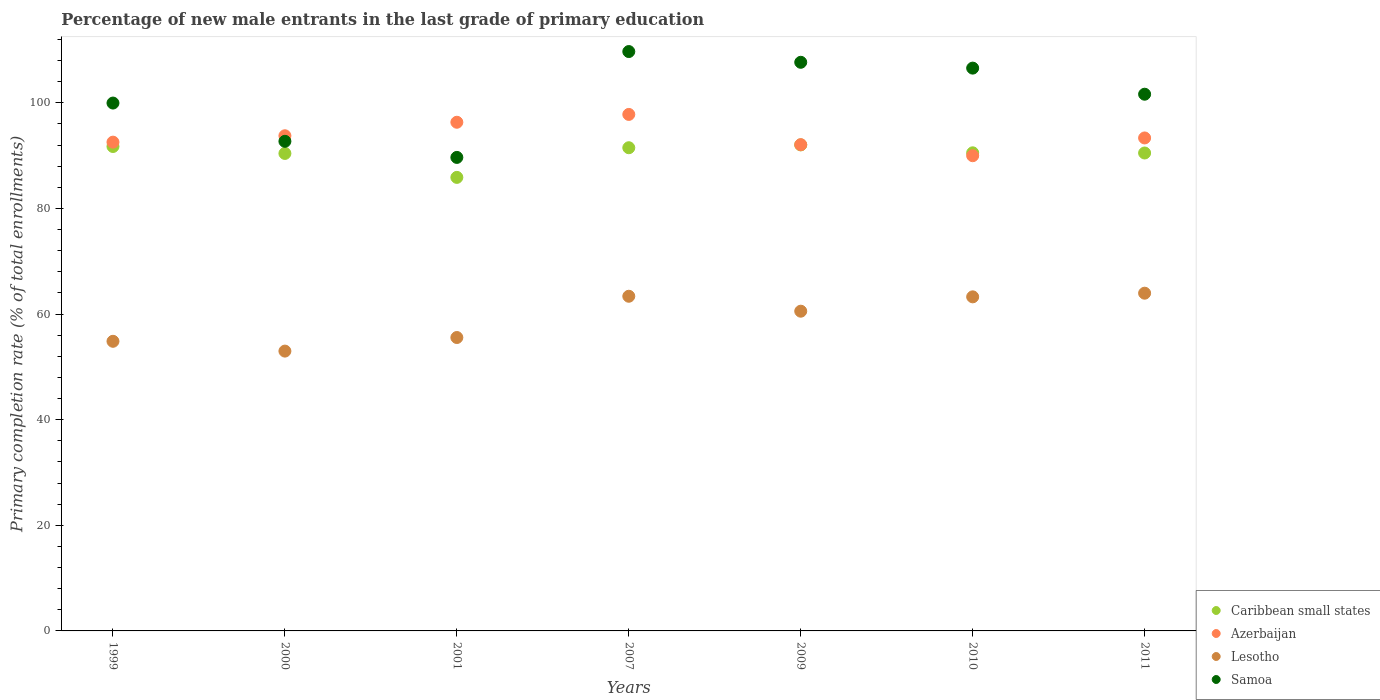How many different coloured dotlines are there?
Make the answer very short. 4. Is the number of dotlines equal to the number of legend labels?
Make the answer very short. Yes. What is the percentage of new male entrants in Azerbaijan in 2007?
Provide a succinct answer. 97.8. Across all years, what is the maximum percentage of new male entrants in Samoa?
Your answer should be compact. 109.71. Across all years, what is the minimum percentage of new male entrants in Lesotho?
Your answer should be very brief. 52.99. What is the total percentage of new male entrants in Azerbaijan in the graph?
Offer a very short reply. 655.86. What is the difference between the percentage of new male entrants in Lesotho in 2000 and that in 2009?
Give a very brief answer. -7.56. What is the difference between the percentage of new male entrants in Azerbaijan in 1999 and the percentage of new male entrants in Caribbean small states in 2009?
Offer a very short reply. 0.52. What is the average percentage of new male entrants in Samoa per year?
Your answer should be very brief. 101.13. In the year 1999, what is the difference between the percentage of new male entrants in Caribbean small states and percentage of new male entrants in Lesotho?
Your response must be concise. 36.89. What is the ratio of the percentage of new male entrants in Lesotho in 1999 to that in 2009?
Keep it short and to the point. 0.91. What is the difference between the highest and the second highest percentage of new male entrants in Azerbaijan?
Your answer should be very brief. 1.48. What is the difference between the highest and the lowest percentage of new male entrants in Lesotho?
Your response must be concise. 10.97. Is it the case that in every year, the sum of the percentage of new male entrants in Caribbean small states and percentage of new male entrants in Lesotho  is greater than the sum of percentage of new male entrants in Azerbaijan and percentage of new male entrants in Samoa?
Ensure brevity in your answer.  Yes. Is it the case that in every year, the sum of the percentage of new male entrants in Caribbean small states and percentage of new male entrants in Azerbaijan  is greater than the percentage of new male entrants in Samoa?
Your answer should be very brief. Yes. Is the percentage of new male entrants in Caribbean small states strictly greater than the percentage of new male entrants in Azerbaijan over the years?
Your response must be concise. No. Is the percentage of new male entrants in Samoa strictly less than the percentage of new male entrants in Caribbean small states over the years?
Provide a succinct answer. No. Does the graph contain any zero values?
Provide a succinct answer. No. Does the graph contain grids?
Provide a succinct answer. No. Where does the legend appear in the graph?
Make the answer very short. Bottom right. What is the title of the graph?
Offer a terse response. Percentage of new male entrants in the last grade of primary education. Does "Mauritius" appear as one of the legend labels in the graph?
Ensure brevity in your answer.  No. What is the label or title of the X-axis?
Keep it short and to the point. Years. What is the label or title of the Y-axis?
Make the answer very short. Primary completion rate (% of total enrollments). What is the Primary completion rate (% of total enrollments) in Caribbean small states in 1999?
Your response must be concise. 91.73. What is the Primary completion rate (% of total enrollments) in Azerbaijan in 1999?
Offer a terse response. 92.55. What is the Primary completion rate (% of total enrollments) in Lesotho in 1999?
Keep it short and to the point. 54.84. What is the Primary completion rate (% of total enrollments) of Samoa in 1999?
Offer a very short reply. 99.96. What is the Primary completion rate (% of total enrollments) in Caribbean small states in 2000?
Your answer should be compact. 90.42. What is the Primary completion rate (% of total enrollments) of Azerbaijan in 2000?
Provide a succinct answer. 93.77. What is the Primary completion rate (% of total enrollments) of Lesotho in 2000?
Provide a succinct answer. 52.99. What is the Primary completion rate (% of total enrollments) of Samoa in 2000?
Your response must be concise. 92.71. What is the Primary completion rate (% of total enrollments) in Caribbean small states in 2001?
Provide a short and direct response. 85.88. What is the Primary completion rate (% of total enrollments) of Azerbaijan in 2001?
Provide a short and direct response. 96.32. What is the Primary completion rate (% of total enrollments) of Lesotho in 2001?
Give a very brief answer. 55.56. What is the Primary completion rate (% of total enrollments) of Samoa in 2001?
Keep it short and to the point. 89.66. What is the Primary completion rate (% of total enrollments) of Caribbean small states in 2007?
Ensure brevity in your answer.  91.5. What is the Primary completion rate (% of total enrollments) of Azerbaijan in 2007?
Offer a terse response. 97.8. What is the Primary completion rate (% of total enrollments) of Lesotho in 2007?
Your answer should be very brief. 63.37. What is the Primary completion rate (% of total enrollments) in Samoa in 2007?
Your answer should be compact. 109.71. What is the Primary completion rate (% of total enrollments) in Caribbean small states in 2009?
Provide a succinct answer. 92.03. What is the Primary completion rate (% of total enrollments) in Azerbaijan in 2009?
Provide a short and direct response. 92.08. What is the Primary completion rate (% of total enrollments) in Lesotho in 2009?
Your answer should be very brief. 60.54. What is the Primary completion rate (% of total enrollments) of Samoa in 2009?
Make the answer very short. 107.68. What is the Primary completion rate (% of total enrollments) in Caribbean small states in 2010?
Provide a succinct answer. 90.53. What is the Primary completion rate (% of total enrollments) in Azerbaijan in 2010?
Make the answer very short. 89.99. What is the Primary completion rate (% of total enrollments) of Lesotho in 2010?
Keep it short and to the point. 63.26. What is the Primary completion rate (% of total enrollments) of Samoa in 2010?
Offer a terse response. 106.57. What is the Primary completion rate (% of total enrollments) in Caribbean small states in 2011?
Offer a very short reply. 90.5. What is the Primary completion rate (% of total enrollments) in Azerbaijan in 2011?
Your answer should be compact. 93.35. What is the Primary completion rate (% of total enrollments) in Lesotho in 2011?
Your response must be concise. 63.95. What is the Primary completion rate (% of total enrollments) in Samoa in 2011?
Give a very brief answer. 101.63. Across all years, what is the maximum Primary completion rate (% of total enrollments) of Caribbean small states?
Your response must be concise. 92.03. Across all years, what is the maximum Primary completion rate (% of total enrollments) of Azerbaijan?
Make the answer very short. 97.8. Across all years, what is the maximum Primary completion rate (% of total enrollments) of Lesotho?
Offer a very short reply. 63.95. Across all years, what is the maximum Primary completion rate (% of total enrollments) of Samoa?
Your answer should be compact. 109.71. Across all years, what is the minimum Primary completion rate (% of total enrollments) of Caribbean small states?
Offer a terse response. 85.88. Across all years, what is the minimum Primary completion rate (% of total enrollments) of Azerbaijan?
Offer a very short reply. 89.99. Across all years, what is the minimum Primary completion rate (% of total enrollments) in Lesotho?
Provide a short and direct response. 52.99. Across all years, what is the minimum Primary completion rate (% of total enrollments) in Samoa?
Provide a succinct answer. 89.66. What is the total Primary completion rate (% of total enrollments) in Caribbean small states in the graph?
Provide a short and direct response. 632.6. What is the total Primary completion rate (% of total enrollments) in Azerbaijan in the graph?
Provide a succinct answer. 655.86. What is the total Primary completion rate (% of total enrollments) in Lesotho in the graph?
Offer a very short reply. 414.52. What is the total Primary completion rate (% of total enrollments) of Samoa in the graph?
Make the answer very short. 707.92. What is the difference between the Primary completion rate (% of total enrollments) in Caribbean small states in 1999 and that in 2000?
Your response must be concise. 1.31. What is the difference between the Primary completion rate (% of total enrollments) of Azerbaijan in 1999 and that in 2000?
Offer a very short reply. -1.21. What is the difference between the Primary completion rate (% of total enrollments) in Lesotho in 1999 and that in 2000?
Your answer should be compact. 1.86. What is the difference between the Primary completion rate (% of total enrollments) of Samoa in 1999 and that in 2000?
Offer a terse response. 7.25. What is the difference between the Primary completion rate (% of total enrollments) in Caribbean small states in 1999 and that in 2001?
Provide a succinct answer. 5.85. What is the difference between the Primary completion rate (% of total enrollments) of Azerbaijan in 1999 and that in 2001?
Ensure brevity in your answer.  -3.77. What is the difference between the Primary completion rate (% of total enrollments) of Lesotho in 1999 and that in 2001?
Give a very brief answer. -0.72. What is the difference between the Primary completion rate (% of total enrollments) in Samoa in 1999 and that in 2001?
Make the answer very short. 10.29. What is the difference between the Primary completion rate (% of total enrollments) of Caribbean small states in 1999 and that in 2007?
Offer a very short reply. 0.23. What is the difference between the Primary completion rate (% of total enrollments) of Azerbaijan in 1999 and that in 2007?
Your answer should be compact. -5.25. What is the difference between the Primary completion rate (% of total enrollments) of Lesotho in 1999 and that in 2007?
Your answer should be very brief. -8.53. What is the difference between the Primary completion rate (% of total enrollments) of Samoa in 1999 and that in 2007?
Offer a terse response. -9.75. What is the difference between the Primary completion rate (% of total enrollments) of Caribbean small states in 1999 and that in 2009?
Offer a terse response. -0.3. What is the difference between the Primary completion rate (% of total enrollments) of Azerbaijan in 1999 and that in 2009?
Give a very brief answer. 0.48. What is the difference between the Primary completion rate (% of total enrollments) of Lesotho in 1999 and that in 2009?
Give a very brief answer. -5.7. What is the difference between the Primary completion rate (% of total enrollments) of Samoa in 1999 and that in 2009?
Give a very brief answer. -7.72. What is the difference between the Primary completion rate (% of total enrollments) of Caribbean small states in 1999 and that in 2010?
Provide a succinct answer. 1.2. What is the difference between the Primary completion rate (% of total enrollments) of Azerbaijan in 1999 and that in 2010?
Keep it short and to the point. 2.57. What is the difference between the Primary completion rate (% of total enrollments) of Lesotho in 1999 and that in 2010?
Offer a terse response. -8.42. What is the difference between the Primary completion rate (% of total enrollments) in Samoa in 1999 and that in 2010?
Offer a very short reply. -6.62. What is the difference between the Primary completion rate (% of total enrollments) in Caribbean small states in 1999 and that in 2011?
Your answer should be very brief. 1.23. What is the difference between the Primary completion rate (% of total enrollments) of Azerbaijan in 1999 and that in 2011?
Offer a terse response. -0.79. What is the difference between the Primary completion rate (% of total enrollments) in Lesotho in 1999 and that in 2011?
Provide a succinct answer. -9.11. What is the difference between the Primary completion rate (% of total enrollments) in Samoa in 1999 and that in 2011?
Provide a short and direct response. -1.67. What is the difference between the Primary completion rate (% of total enrollments) in Caribbean small states in 2000 and that in 2001?
Ensure brevity in your answer.  4.53. What is the difference between the Primary completion rate (% of total enrollments) of Azerbaijan in 2000 and that in 2001?
Give a very brief answer. -2.56. What is the difference between the Primary completion rate (% of total enrollments) in Lesotho in 2000 and that in 2001?
Give a very brief answer. -2.57. What is the difference between the Primary completion rate (% of total enrollments) in Samoa in 2000 and that in 2001?
Your answer should be very brief. 3.05. What is the difference between the Primary completion rate (% of total enrollments) in Caribbean small states in 2000 and that in 2007?
Offer a very short reply. -1.08. What is the difference between the Primary completion rate (% of total enrollments) in Azerbaijan in 2000 and that in 2007?
Ensure brevity in your answer.  -4.04. What is the difference between the Primary completion rate (% of total enrollments) of Lesotho in 2000 and that in 2007?
Keep it short and to the point. -10.38. What is the difference between the Primary completion rate (% of total enrollments) in Samoa in 2000 and that in 2007?
Your answer should be compact. -17. What is the difference between the Primary completion rate (% of total enrollments) of Caribbean small states in 2000 and that in 2009?
Offer a terse response. -1.62. What is the difference between the Primary completion rate (% of total enrollments) in Azerbaijan in 2000 and that in 2009?
Your response must be concise. 1.69. What is the difference between the Primary completion rate (% of total enrollments) in Lesotho in 2000 and that in 2009?
Your response must be concise. -7.56. What is the difference between the Primary completion rate (% of total enrollments) of Samoa in 2000 and that in 2009?
Offer a very short reply. -14.96. What is the difference between the Primary completion rate (% of total enrollments) in Caribbean small states in 2000 and that in 2010?
Ensure brevity in your answer.  -0.12. What is the difference between the Primary completion rate (% of total enrollments) of Azerbaijan in 2000 and that in 2010?
Make the answer very short. 3.78. What is the difference between the Primary completion rate (% of total enrollments) of Lesotho in 2000 and that in 2010?
Give a very brief answer. -10.27. What is the difference between the Primary completion rate (% of total enrollments) of Samoa in 2000 and that in 2010?
Your answer should be very brief. -13.86. What is the difference between the Primary completion rate (% of total enrollments) of Caribbean small states in 2000 and that in 2011?
Your response must be concise. -0.08. What is the difference between the Primary completion rate (% of total enrollments) of Azerbaijan in 2000 and that in 2011?
Make the answer very short. 0.42. What is the difference between the Primary completion rate (% of total enrollments) of Lesotho in 2000 and that in 2011?
Give a very brief answer. -10.97. What is the difference between the Primary completion rate (% of total enrollments) in Samoa in 2000 and that in 2011?
Give a very brief answer. -8.92. What is the difference between the Primary completion rate (% of total enrollments) of Caribbean small states in 2001 and that in 2007?
Offer a very short reply. -5.62. What is the difference between the Primary completion rate (% of total enrollments) in Azerbaijan in 2001 and that in 2007?
Provide a short and direct response. -1.48. What is the difference between the Primary completion rate (% of total enrollments) of Lesotho in 2001 and that in 2007?
Provide a succinct answer. -7.81. What is the difference between the Primary completion rate (% of total enrollments) in Samoa in 2001 and that in 2007?
Make the answer very short. -20.05. What is the difference between the Primary completion rate (% of total enrollments) of Caribbean small states in 2001 and that in 2009?
Offer a terse response. -6.15. What is the difference between the Primary completion rate (% of total enrollments) of Azerbaijan in 2001 and that in 2009?
Offer a very short reply. 4.25. What is the difference between the Primary completion rate (% of total enrollments) of Lesotho in 2001 and that in 2009?
Make the answer very short. -4.98. What is the difference between the Primary completion rate (% of total enrollments) in Samoa in 2001 and that in 2009?
Provide a short and direct response. -18.01. What is the difference between the Primary completion rate (% of total enrollments) in Caribbean small states in 2001 and that in 2010?
Provide a succinct answer. -4.65. What is the difference between the Primary completion rate (% of total enrollments) of Azerbaijan in 2001 and that in 2010?
Offer a very short reply. 6.33. What is the difference between the Primary completion rate (% of total enrollments) of Lesotho in 2001 and that in 2010?
Your response must be concise. -7.7. What is the difference between the Primary completion rate (% of total enrollments) in Samoa in 2001 and that in 2010?
Make the answer very short. -16.91. What is the difference between the Primary completion rate (% of total enrollments) in Caribbean small states in 2001 and that in 2011?
Your answer should be compact. -4.62. What is the difference between the Primary completion rate (% of total enrollments) of Azerbaijan in 2001 and that in 2011?
Your answer should be very brief. 2.97. What is the difference between the Primary completion rate (% of total enrollments) of Lesotho in 2001 and that in 2011?
Give a very brief answer. -8.39. What is the difference between the Primary completion rate (% of total enrollments) in Samoa in 2001 and that in 2011?
Offer a very short reply. -11.97. What is the difference between the Primary completion rate (% of total enrollments) of Caribbean small states in 2007 and that in 2009?
Your answer should be compact. -0.54. What is the difference between the Primary completion rate (% of total enrollments) of Azerbaijan in 2007 and that in 2009?
Provide a short and direct response. 5.73. What is the difference between the Primary completion rate (% of total enrollments) of Lesotho in 2007 and that in 2009?
Give a very brief answer. 2.83. What is the difference between the Primary completion rate (% of total enrollments) of Samoa in 2007 and that in 2009?
Your answer should be very brief. 2.03. What is the difference between the Primary completion rate (% of total enrollments) in Caribbean small states in 2007 and that in 2010?
Your response must be concise. 0.96. What is the difference between the Primary completion rate (% of total enrollments) in Azerbaijan in 2007 and that in 2010?
Your answer should be compact. 7.82. What is the difference between the Primary completion rate (% of total enrollments) of Lesotho in 2007 and that in 2010?
Your response must be concise. 0.11. What is the difference between the Primary completion rate (% of total enrollments) in Samoa in 2007 and that in 2010?
Keep it short and to the point. 3.14. What is the difference between the Primary completion rate (% of total enrollments) of Azerbaijan in 2007 and that in 2011?
Offer a very short reply. 4.46. What is the difference between the Primary completion rate (% of total enrollments) in Lesotho in 2007 and that in 2011?
Your answer should be compact. -0.58. What is the difference between the Primary completion rate (% of total enrollments) in Samoa in 2007 and that in 2011?
Your answer should be compact. 8.08. What is the difference between the Primary completion rate (% of total enrollments) in Caribbean small states in 2009 and that in 2010?
Ensure brevity in your answer.  1.5. What is the difference between the Primary completion rate (% of total enrollments) of Azerbaijan in 2009 and that in 2010?
Provide a succinct answer. 2.09. What is the difference between the Primary completion rate (% of total enrollments) of Lesotho in 2009 and that in 2010?
Provide a succinct answer. -2.72. What is the difference between the Primary completion rate (% of total enrollments) of Samoa in 2009 and that in 2010?
Offer a very short reply. 1.1. What is the difference between the Primary completion rate (% of total enrollments) of Caribbean small states in 2009 and that in 2011?
Make the answer very short. 1.53. What is the difference between the Primary completion rate (% of total enrollments) of Azerbaijan in 2009 and that in 2011?
Your response must be concise. -1.27. What is the difference between the Primary completion rate (% of total enrollments) of Lesotho in 2009 and that in 2011?
Provide a succinct answer. -3.41. What is the difference between the Primary completion rate (% of total enrollments) in Samoa in 2009 and that in 2011?
Offer a very short reply. 6.05. What is the difference between the Primary completion rate (% of total enrollments) in Caribbean small states in 2010 and that in 2011?
Ensure brevity in your answer.  0.03. What is the difference between the Primary completion rate (% of total enrollments) of Azerbaijan in 2010 and that in 2011?
Offer a very short reply. -3.36. What is the difference between the Primary completion rate (% of total enrollments) of Lesotho in 2010 and that in 2011?
Offer a terse response. -0.69. What is the difference between the Primary completion rate (% of total enrollments) of Samoa in 2010 and that in 2011?
Give a very brief answer. 4.94. What is the difference between the Primary completion rate (% of total enrollments) in Caribbean small states in 1999 and the Primary completion rate (% of total enrollments) in Azerbaijan in 2000?
Make the answer very short. -2.03. What is the difference between the Primary completion rate (% of total enrollments) in Caribbean small states in 1999 and the Primary completion rate (% of total enrollments) in Lesotho in 2000?
Your response must be concise. 38.74. What is the difference between the Primary completion rate (% of total enrollments) of Caribbean small states in 1999 and the Primary completion rate (% of total enrollments) of Samoa in 2000?
Make the answer very short. -0.98. What is the difference between the Primary completion rate (% of total enrollments) of Azerbaijan in 1999 and the Primary completion rate (% of total enrollments) of Lesotho in 2000?
Provide a short and direct response. 39.57. What is the difference between the Primary completion rate (% of total enrollments) in Azerbaijan in 1999 and the Primary completion rate (% of total enrollments) in Samoa in 2000?
Provide a short and direct response. -0.16. What is the difference between the Primary completion rate (% of total enrollments) of Lesotho in 1999 and the Primary completion rate (% of total enrollments) of Samoa in 2000?
Your response must be concise. -37.87. What is the difference between the Primary completion rate (% of total enrollments) of Caribbean small states in 1999 and the Primary completion rate (% of total enrollments) of Azerbaijan in 2001?
Ensure brevity in your answer.  -4.59. What is the difference between the Primary completion rate (% of total enrollments) of Caribbean small states in 1999 and the Primary completion rate (% of total enrollments) of Lesotho in 2001?
Your response must be concise. 36.17. What is the difference between the Primary completion rate (% of total enrollments) of Caribbean small states in 1999 and the Primary completion rate (% of total enrollments) of Samoa in 2001?
Offer a very short reply. 2.07. What is the difference between the Primary completion rate (% of total enrollments) in Azerbaijan in 1999 and the Primary completion rate (% of total enrollments) in Lesotho in 2001?
Give a very brief answer. 36.99. What is the difference between the Primary completion rate (% of total enrollments) in Azerbaijan in 1999 and the Primary completion rate (% of total enrollments) in Samoa in 2001?
Offer a terse response. 2.89. What is the difference between the Primary completion rate (% of total enrollments) in Lesotho in 1999 and the Primary completion rate (% of total enrollments) in Samoa in 2001?
Offer a terse response. -34.82. What is the difference between the Primary completion rate (% of total enrollments) of Caribbean small states in 1999 and the Primary completion rate (% of total enrollments) of Azerbaijan in 2007?
Offer a terse response. -6.07. What is the difference between the Primary completion rate (% of total enrollments) of Caribbean small states in 1999 and the Primary completion rate (% of total enrollments) of Lesotho in 2007?
Offer a very short reply. 28.36. What is the difference between the Primary completion rate (% of total enrollments) of Caribbean small states in 1999 and the Primary completion rate (% of total enrollments) of Samoa in 2007?
Your response must be concise. -17.98. What is the difference between the Primary completion rate (% of total enrollments) of Azerbaijan in 1999 and the Primary completion rate (% of total enrollments) of Lesotho in 2007?
Provide a short and direct response. 29.18. What is the difference between the Primary completion rate (% of total enrollments) in Azerbaijan in 1999 and the Primary completion rate (% of total enrollments) in Samoa in 2007?
Give a very brief answer. -17.16. What is the difference between the Primary completion rate (% of total enrollments) of Lesotho in 1999 and the Primary completion rate (% of total enrollments) of Samoa in 2007?
Keep it short and to the point. -54.87. What is the difference between the Primary completion rate (% of total enrollments) of Caribbean small states in 1999 and the Primary completion rate (% of total enrollments) of Azerbaijan in 2009?
Provide a short and direct response. -0.34. What is the difference between the Primary completion rate (% of total enrollments) of Caribbean small states in 1999 and the Primary completion rate (% of total enrollments) of Lesotho in 2009?
Ensure brevity in your answer.  31.19. What is the difference between the Primary completion rate (% of total enrollments) of Caribbean small states in 1999 and the Primary completion rate (% of total enrollments) of Samoa in 2009?
Your answer should be very brief. -15.94. What is the difference between the Primary completion rate (% of total enrollments) of Azerbaijan in 1999 and the Primary completion rate (% of total enrollments) of Lesotho in 2009?
Your response must be concise. 32.01. What is the difference between the Primary completion rate (% of total enrollments) in Azerbaijan in 1999 and the Primary completion rate (% of total enrollments) in Samoa in 2009?
Keep it short and to the point. -15.12. What is the difference between the Primary completion rate (% of total enrollments) in Lesotho in 1999 and the Primary completion rate (% of total enrollments) in Samoa in 2009?
Your answer should be very brief. -52.83. What is the difference between the Primary completion rate (% of total enrollments) in Caribbean small states in 1999 and the Primary completion rate (% of total enrollments) in Azerbaijan in 2010?
Your response must be concise. 1.74. What is the difference between the Primary completion rate (% of total enrollments) of Caribbean small states in 1999 and the Primary completion rate (% of total enrollments) of Lesotho in 2010?
Offer a terse response. 28.47. What is the difference between the Primary completion rate (% of total enrollments) of Caribbean small states in 1999 and the Primary completion rate (% of total enrollments) of Samoa in 2010?
Your answer should be very brief. -14.84. What is the difference between the Primary completion rate (% of total enrollments) in Azerbaijan in 1999 and the Primary completion rate (% of total enrollments) in Lesotho in 2010?
Make the answer very short. 29.29. What is the difference between the Primary completion rate (% of total enrollments) of Azerbaijan in 1999 and the Primary completion rate (% of total enrollments) of Samoa in 2010?
Ensure brevity in your answer.  -14.02. What is the difference between the Primary completion rate (% of total enrollments) of Lesotho in 1999 and the Primary completion rate (% of total enrollments) of Samoa in 2010?
Your answer should be very brief. -51.73. What is the difference between the Primary completion rate (% of total enrollments) in Caribbean small states in 1999 and the Primary completion rate (% of total enrollments) in Azerbaijan in 2011?
Ensure brevity in your answer.  -1.62. What is the difference between the Primary completion rate (% of total enrollments) of Caribbean small states in 1999 and the Primary completion rate (% of total enrollments) of Lesotho in 2011?
Provide a short and direct response. 27.78. What is the difference between the Primary completion rate (% of total enrollments) in Caribbean small states in 1999 and the Primary completion rate (% of total enrollments) in Samoa in 2011?
Ensure brevity in your answer.  -9.9. What is the difference between the Primary completion rate (% of total enrollments) of Azerbaijan in 1999 and the Primary completion rate (% of total enrollments) of Lesotho in 2011?
Give a very brief answer. 28.6. What is the difference between the Primary completion rate (% of total enrollments) of Azerbaijan in 1999 and the Primary completion rate (% of total enrollments) of Samoa in 2011?
Your response must be concise. -9.08. What is the difference between the Primary completion rate (% of total enrollments) in Lesotho in 1999 and the Primary completion rate (% of total enrollments) in Samoa in 2011?
Keep it short and to the point. -46.79. What is the difference between the Primary completion rate (% of total enrollments) of Caribbean small states in 2000 and the Primary completion rate (% of total enrollments) of Azerbaijan in 2001?
Provide a short and direct response. -5.91. What is the difference between the Primary completion rate (% of total enrollments) in Caribbean small states in 2000 and the Primary completion rate (% of total enrollments) in Lesotho in 2001?
Make the answer very short. 34.86. What is the difference between the Primary completion rate (% of total enrollments) of Caribbean small states in 2000 and the Primary completion rate (% of total enrollments) of Samoa in 2001?
Make the answer very short. 0.75. What is the difference between the Primary completion rate (% of total enrollments) in Azerbaijan in 2000 and the Primary completion rate (% of total enrollments) in Lesotho in 2001?
Make the answer very short. 38.21. What is the difference between the Primary completion rate (% of total enrollments) in Azerbaijan in 2000 and the Primary completion rate (% of total enrollments) in Samoa in 2001?
Your response must be concise. 4.1. What is the difference between the Primary completion rate (% of total enrollments) in Lesotho in 2000 and the Primary completion rate (% of total enrollments) in Samoa in 2001?
Offer a terse response. -36.68. What is the difference between the Primary completion rate (% of total enrollments) of Caribbean small states in 2000 and the Primary completion rate (% of total enrollments) of Azerbaijan in 2007?
Make the answer very short. -7.39. What is the difference between the Primary completion rate (% of total enrollments) of Caribbean small states in 2000 and the Primary completion rate (% of total enrollments) of Lesotho in 2007?
Offer a terse response. 27.04. What is the difference between the Primary completion rate (% of total enrollments) in Caribbean small states in 2000 and the Primary completion rate (% of total enrollments) in Samoa in 2007?
Offer a very short reply. -19.29. What is the difference between the Primary completion rate (% of total enrollments) of Azerbaijan in 2000 and the Primary completion rate (% of total enrollments) of Lesotho in 2007?
Give a very brief answer. 30.39. What is the difference between the Primary completion rate (% of total enrollments) of Azerbaijan in 2000 and the Primary completion rate (% of total enrollments) of Samoa in 2007?
Your answer should be very brief. -15.94. What is the difference between the Primary completion rate (% of total enrollments) in Lesotho in 2000 and the Primary completion rate (% of total enrollments) in Samoa in 2007?
Provide a short and direct response. -56.72. What is the difference between the Primary completion rate (% of total enrollments) in Caribbean small states in 2000 and the Primary completion rate (% of total enrollments) in Azerbaijan in 2009?
Offer a terse response. -1.66. What is the difference between the Primary completion rate (% of total enrollments) in Caribbean small states in 2000 and the Primary completion rate (% of total enrollments) in Lesotho in 2009?
Your response must be concise. 29.87. What is the difference between the Primary completion rate (% of total enrollments) in Caribbean small states in 2000 and the Primary completion rate (% of total enrollments) in Samoa in 2009?
Your answer should be very brief. -17.26. What is the difference between the Primary completion rate (% of total enrollments) of Azerbaijan in 2000 and the Primary completion rate (% of total enrollments) of Lesotho in 2009?
Your answer should be compact. 33.22. What is the difference between the Primary completion rate (% of total enrollments) in Azerbaijan in 2000 and the Primary completion rate (% of total enrollments) in Samoa in 2009?
Offer a very short reply. -13.91. What is the difference between the Primary completion rate (% of total enrollments) of Lesotho in 2000 and the Primary completion rate (% of total enrollments) of Samoa in 2009?
Make the answer very short. -54.69. What is the difference between the Primary completion rate (% of total enrollments) of Caribbean small states in 2000 and the Primary completion rate (% of total enrollments) of Azerbaijan in 2010?
Your response must be concise. 0.43. What is the difference between the Primary completion rate (% of total enrollments) in Caribbean small states in 2000 and the Primary completion rate (% of total enrollments) in Lesotho in 2010?
Provide a short and direct response. 27.16. What is the difference between the Primary completion rate (% of total enrollments) of Caribbean small states in 2000 and the Primary completion rate (% of total enrollments) of Samoa in 2010?
Your answer should be compact. -16.16. What is the difference between the Primary completion rate (% of total enrollments) in Azerbaijan in 2000 and the Primary completion rate (% of total enrollments) in Lesotho in 2010?
Give a very brief answer. 30.5. What is the difference between the Primary completion rate (% of total enrollments) in Azerbaijan in 2000 and the Primary completion rate (% of total enrollments) in Samoa in 2010?
Your answer should be compact. -12.81. What is the difference between the Primary completion rate (% of total enrollments) in Lesotho in 2000 and the Primary completion rate (% of total enrollments) in Samoa in 2010?
Make the answer very short. -53.59. What is the difference between the Primary completion rate (% of total enrollments) of Caribbean small states in 2000 and the Primary completion rate (% of total enrollments) of Azerbaijan in 2011?
Make the answer very short. -2.93. What is the difference between the Primary completion rate (% of total enrollments) of Caribbean small states in 2000 and the Primary completion rate (% of total enrollments) of Lesotho in 2011?
Offer a very short reply. 26.46. What is the difference between the Primary completion rate (% of total enrollments) in Caribbean small states in 2000 and the Primary completion rate (% of total enrollments) in Samoa in 2011?
Give a very brief answer. -11.21. What is the difference between the Primary completion rate (% of total enrollments) in Azerbaijan in 2000 and the Primary completion rate (% of total enrollments) in Lesotho in 2011?
Offer a terse response. 29.81. What is the difference between the Primary completion rate (% of total enrollments) in Azerbaijan in 2000 and the Primary completion rate (% of total enrollments) in Samoa in 2011?
Your answer should be very brief. -7.87. What is the difference between the Primary completion rate (% of total enrollments) of Lesotho in 2000 and the Primary completion rate (% of total enrollments) of Samoa in 2011?
Give a very brief answer. -48.64. What is the difference between the Primary completion rate (% of total enrollments) in Caribbean small states in 2001 and the Primary completion rate (% of total enrollments) in Azerbaijan in 2007?
Your response must be concise. -11.92. What is the difference between the Primary completion rate (% of total enrollments) in Caribbean small states in 2001 and the Primary completion rate (% of total enrollments) in Lesotho in 2007?
Provide a succinct answer. 22.51. What is the difference between the Primary completion rate (% of total enrollments) in Caribbean small states in 2001 and the Primary completion rate (% of total enrollments) in Samoa in 2007?
Give a very brief answer. -23.83. What is the difference between the Primary completion rate (% of total enrollments) of Azerbaijan in 2001 and the Primary completion rate (% of total enrollments) of Lesotho in 2007?
Offer a terse response. 32.95. What is the difference between the Primary completion rate (% of total enrollments) in Azerbaijan in 2001 and the Primary completion rate (% of total enrollments) in Samoa in 2007?
Offer a very short reply. -13.39. What is the difference between the Primary completion rate (% of total enrollments) of Lesotho in 2001 and the Primary completion rate (% of total enrollments) of Samoa in 2007?
Keep it short and to the point. -54.15. What is the difference between the Primary completion rate (% of total enrollments) of Caribbean small states in 2001 and the Primary completion rate (% of total enrollments) of Azerbaijan in 2009?
Provide a short and direct response. -6.19. What is the difference between the Primary completion rate (% of total enrollments) of Caribbean small states in 2001 and the Primary completion rate (% of total enrollments) of Lesotho in 2009?
Make the answer very short. 25.34. What is the difference between the Primary completion rate (% of total enrollments) in Caribbean small states in 2001 and the Primary completion rate (% of total enrollments) in Samoa in 2009?
Your answer should be very brief. -21.79. What is the difference between the Primary completion rate (% of total enrollments) in Azerbaijan in 2001 and the Primary completion rate (% of total enrollments) in Lesotho in 2009?
Ensure brevity in your answer.  35.78. What is the difference between the Primary completion rate (% of total enrollments) in Azerbaijan in 2001 and the Primary completion rate (% of total enrollments) in Samoa in 2009?
Your answer should be very brief. -11.35. What is the difference between the Primary completion rate (% of total enrollments) in Lesotho in 2001 and the Primary completion rate (% of total enrollments) in Samoa in 2009?
Make the answer very short. -52.12. What is the difference between the Primary completion rate (% of total enrollments) in Caribbean small states in 2001 and the Primary completion rate (% of total enrollments) in Azerbaijan in 2010?
Provide a succinct answer. -4.1. What is the difference between the Primary completion rate (% of total enrollments) of Caribbean small states in 2001 and the Primary completion rate (% of total enrollments) of Lesotho in 2010?
Your response must be concise. 22.62. What is the difference between the Primary completion rate (% of total enrollments) of Caribbean small states in 2001 and the Primary completion rate (% of total enrollments) of Samoa in 2010?
Provide a succinct answer. -20.69. What is the difference between the Primary completion rate (% of total enrollments) of Azerbaijan in 2001 and the Primary completion rate (% of total enrollments) of Lesotho in 2010?
Keep it short and to the point. 33.06. What is the difference between the Primary completion rate (% of total enrollments) in Azerbaijan in 2001 and the Primary completion rate (% of total enrollments) in Samoa in 2010?
Your response must be concise. -10.25. What is the difference between the Primary completion rate (% of total enrollments) of Lesotho in 2001 and the Primary completion rate (% of total enrollments) of Samoa in 2010?
Your answer should be very brief. -51.01. What is the difference between the Primary completion rate (% of total enrollments) in Caribbean small states in 2001 and the Primary completion rate (% of total enrollments) in Azerbaijan in 2011?
Ensure brevity in your answer.  -7.47. What is the difference between the Primary completion rate (% of total enrollments) of Caribbean small states in 2001 and the Primary completion rate (% of total enrollments) of Lesotho in 2011?
Keep it short and to the point. 21.93. What is the difference between the Primary completion rate (% of total enrollments) of Caribbean small states in 2001 and the Primary completion rate (% of total enrollments) of Samoa in 2011?
Provide a succinct answer. -15.75. What is the difference between the Primary completion rate (% of total enrollments) in Azerbaijan in 2001 and the Primary completion rate (% of total enrollments) in Lesotho in 2011?
Make the answer very short. 32.37. What is the difference between the Primary completion rate (% of total enrollments) of Azerbaijan in 2001 and the Primary completion rate (% of total enrollments) of Samoa in 2011?
Provide a short and direct response. -5.31. What is the difference between the Primary completion rate (% of total enrollments) in Lesotho in 2001 and the Primary completion rate (% of total enrollments) in Samoa in 2011?
Provide a succinct answer. -46.07. What is the difference between the Primary completion rate (% of total enrollments) of Caribbean small states in 2007 and the Primary completion rate (% of total enrollments) of Azerbaijan in 2009?
Provide a succinct answer. -0.58. What is the difference between the Primary completion rate (% of total enrollments) in Caribbean small states in 2007 and the Primary completion rate (% of total enrollments) in Lesotho in 2009?
Offer a very short reply. 30.95. What is the difference between the Primary completion rate (% of total enrollments) of Caribbean small states in 2007 and the Primary completion rate (% of total enrollments) of Samoa in 2009?
Keep it short and to the point. -16.18. What is the difference between the Primary completion rate (% of total enrollments) of Azerbaijan in 2007 and the Primary completion rate (% of total enrollments) of Lesotho in 2009?
Your response must be concise. 37.26. What is the difference between the Primary completion rate (% of total enrollments) in Azerbaijan in 2007 and the Primary completion rate (% of total enrollments) in Samoa in 2009?
Ensure brevity in your answer.  -9.87. What is the difference between the Primary completion rate (% of total enrollments) of Lesotho in 2007 and the Primary completion rate (% of total enrollments) of Samoa in 2009?
Ensure brevity in your answer.  -44.3. What is the difference between the Primary completion rate (% of total enrollments) in Caribbean small states in 2007 and the Primary completion rate (% of total enrollments) in Azerbaijan in 2010?
Offer a terse response. 1.51. What is the difference between the Primary completion rate (% of total enrollments) in Caribbean small states in 2007 and the Primary completion rate (% of total enrollments) in Lesotho in 2010?
Offer a terse response. 28.24. What is the difference between the Primary completion rate (% of total enrollments) of Caribbean small states in 2007 and the Primary completion rate (% of total enrollments) of Samoa in 2010?
Your answer should be very brief. -15.08. What is the difference between the Primary completion rate (% of total enrollments) in Azerbaijan in 2007 and the Primary completion rate (% of total enrollments) in Lesotho in 2010?
Keep it short and to the point. 34.54. What is the difference between the Primary completion rate (% of total enrollments) in Azerbaijan in 2007 and the Primary completion rate (% of total enrollments) in Samoa in 2010?
Keep it short and to the point. -8.77. What is the difference between the Primary completion rate (% of total enrollments) of Lesotho in 2007 and the Primary completion rate (% of total enrollments) of Samoa in 2010?
Provide a succinct answer. -43.2. What is the difference between the Primary completion rate (% of total enrollments) in Caribbean small states in 2007 and the Primary completion rate (% of total enrollments) in Azerbaijan in 2011?
Provide a short and direct response. -1.85. What is the difference between the Primary completion rate (% of total enrollments) in Caribbean small states in 2007 and the Primary completion rate (% of total enrollments) in Lesotho in 2011?
Provide a short and direct response. 27.55. What is the difference between the Primary completion rate (% of total enrollments) of Caribbean small states in 2007 and the Primary completion rate (% of total enrollments) of Samoa in 2011?
Provide a succinct answer. -10.13. What is the difference between the Primary completion rate (% of total enrollments) in Azerbaijan in 2007 and the Primary completion rate (% of total enrollments) in Lesotho in 2011?
Give a very brief answer. 33.85. What is the difference between the Primary completion rate (% of total enrollments) of Azerbaijan in 2007 and the Primary completion rate (% of total enrollments) of Samoa in 2011?
Offer a very short reply. -3.83. What is the difference between the Primary completion rate (% of total enrollments) in Lesotho in 2007 and the Primary completion rate (% of total enrollments) in Samoa in 2011?
Offer a very short reply. -38.26. What is the difference between the Primary completion rate (% of total enrollments) in Caribbean small states in 2009 and the Primary completion rate (% of total enrollments) in Azerbaijan in 2010?
Offer a terse response. 2.05. What is the difference between the Primary completion rate (% of total enrollments) in Caribbean small states in 2009 and the Primary completion rate (% of total enrollments) in Lesotho in 2010?
Provide a succinct answer. 28.77. What is the difference between the Primary completion rate (% of total enrollments) in Caribbean small states in 2009 and the Primary completion rate (% of total enrollments) in Samoa in 2010?
Provide a short and direct response. -14.54. What is the difference between the Primary completion rate (% of total enrollments) of Azerbaijan in 2009 and the Primary completion rate (% of total enrollments) of Lesotho in 2010?
Keep it short and to the point. 28.81. What is the difference between the Primary completion rate (% of total enrollments) of Azerbaijan in 2009 and the Primary completion rate (% of total enrollments) of Samoa in 2010?
Keep it short and to the point. -14.5. What is the difference between the Primary completion rate (% of total enrollments) in Lesotho in 2009 and the Primary completion rate (% of total enrollments) in Samoa in 2010?
Provide a short and direct response. -46.03. What is the difference between the Primary completion rate (% of total enrollments) in Caribbean small states in 2009 and the Primary completion rate (% of total enrollments) in Azerbaijan in 2011?
Ensure brevity in your answer.  -1.32. What is the difference between the Primary completion rate (% of total enrollments) of Caribbean small states in 2009 and the Primary completion rate (% of total enrollments) of Lesotho in 2011?
Your answer should be compact. 28.08. What is the difference between the Primary completion rate (% of total enrollments) in Caribbean small states in 2009 and the Primary completion rate (% of total enrollments) in Samoa in 2011?
Give a very brief answer. -9.6. What is the difference between the Primary completion rate (% of total enrollments) in Azerbaijan in 2009 and the Primary completion rate (% of total enrollments) in Lesotho in 2011?
Offer a very short reply. 28.12. What is the difference between the Primary completion rate (% of total enrollments) in Azerbaijan in 2009 and the Primary completion rate (% of total enrollments) in Samoa in 2011?
Offer a terse response. -9.56. What is the difference between the Primary completion rate (% of total enrollments) in Lesotho in 2009 and the Primary completion rate (% of total enrollments) in Samoa in 2011?
Offer a very short reply. -41.09. What is the difference between the Primary completion rate (% of total enrollments) in Caribbean small states in 2010 and the Primary completion rate (% of total enrollments) in Azerbaijan in 2011?
Your answer should be compact. -2.82. What is the difference between the Primary completion rate (% of total enrollments) in Caribbean small states in 2010 and the Primary completion rate (% of total enrollments) in Lesotho in 2011?
Your answer should be very brief. 26.58. What is the difference between the Primary completion rate (% of total enrollments) in Caribbean small states in 2010 and the Primary completion rate (% of total enrollments) in Samoa in 2011?
Give a very brief answer. -11.1. What is the difference between the Primary completion rate (% of total enrollments) of Azerbaijan in 2010 and the Primary completion rate (% of total enrollments) of Lesotho in 2011?
Your answer should be compact. 26.03. What is the difference between the Primary completion rate (% of total enrollments) in Azerbaijan in 2010 and the Primary completion rate (% of total enrollments) in Samoa in 2011?
Offer a terse response. -11.64. What is the difference between the Primary completion rate (% of total enrollments) of Lesotho in 2010 and the Primary completion rate (% of total enrollments) of Samoa in 2011?
Your answer should be very brief. -38.37. What is the average Primary completion rate (% of total enrollments) of Caribbean small states per year?
Give a very brief answer. 90.37. What is the average Primary completion rate (% of total enrollments) in Azerbaijan per year?
Provide a short and direct response. 93.69. What is the average Primary completion rate (% of total enrollments) in Lesotho per year?
Your answer should be very brief. 59.22. What is the average Primary completion rate (% of total enrollments) in Samoa per year?
Keep it short and to the point. 101.13. In the year 1999, what is the difference between the Primary completion rate (% of total enrollments) in Caribbean small states and Primary completion rate (% of total enrollments) in Azerbaijan?
Offer a terse response. -0.82. In the year 1999, what is the difference between the Primary completion rate (% of total enrollments) in Caribbean small states and Primary completion rate (% of total enrollments) in Lesotho?
Ensure brevity in your answer.  36.89. In the year 1999, what is the difference between the Primary completion rate (% of total enrollments) in Caribbean small states and Primary completion rate (% of total enrollments) in Samoa?
Provide a succinct answer. -8.22. In the year 1999, what is the difference between the Primary completion rate (% of total enrollments) of Azerbaijan and Primary completion rate (% of total enrollments) of Lesotho?
Ensure brevity in your answer.  37.71. In the year 1999, what is the difference between the Primary completion rate (% of total enrollments) of Azerbaijan and Primary completion rate (% of total enrollments) of Samoa?
Make the answer very short. -7.4. In the year 1999, what is the difference between the Primary completion rate (% of total enrollments) in Lesotho and Primary completion rate (% of total enrollments) in Samoa?
Keep it short and to the point. -45.11. In the year 2000, what is the difference between the Primary completion rate (% of total enrollments) of Caribbean small states and Primary completion rate (% of total enrollments) of Azerbaijan?
Your answer should be very brief. -3.35. In the year 2000, what is the difference between the Primary completion rate (% of total enrollments) of Caribbean small states and Primary completion rate (% of total enrollments) of Lesotho?
Ensure brevity in your answer.  37.43. In the year 2000, what is the difference between the Primary completion rate (% of total enrollments) of Caribbean small states and Primary completion rate (% of total enrollments) of Samoa?
Provide a short and direct response. -2.29. In the year 2000, what is the difference between the Primary completion rate (% of total enrollments) in Azerbaijan and Primary completion rate (% of total enrollments) in Lesotho?
Provide a short and direct response. 40.78. In the year 2000, what is the difference between the Primary completion rate (% of total enrollments) in Azerbaijan and Primary completion rate (% of total enrollments) in Samoa?
Provide a short and direct response. 1.05. In the year 2000, what is the difference between the Primary completion rate (% of total enrollments) in Lesotho and Primary completion rate (% of total enrollments) in Samoa?
Your response must be concise. -39.72. In the year 2001, what is the difference between the Primary completion rate (% of total enrollments) of Caribbean small states and Primary completion rate (% of total enrollments) of Azerbaijan?
Provide a short and direct response. -10.44. In the year 2001, what is the difference between the Primary completion rate (% of total enrollments) in Caribbean small states and Primary completion rate (% of total enrollments) in Lesotho?
Offer a very short reply. 30.32. In the year 2001, what is the difference between the Primary completion rate (% of total enrollments) of Caribbean small states and Primary completion rate (% of total enrollments) of Samoa?
Your answer should be very brief. -3.78. In the year 2001, what is the difference between the Primary completion rate (% of total enrollments) of Azerbaijan and Primary completion rate (% of total enrollments) of Lesotho?
Provide a succinct answer. 40.76. In the year 2001, what is the difference between the Primary completion rate (% of total enrollments) in Azerbaijan and Primary completion rate (% of total enrollments) in Samoa?
Keep it short and to the point. 6.66. In the year 2001, what is the difference between the Primary completion rate (% of total enrollments) in Lesotho and Primary completion rate (% of total enrollments) in Samoa?
Offer a terse response. -34.1. In the year 2007, what is the difference between the Primary completion rate (% of total enrollments) of Caribbean small states and Primary completion rate (% of total enrollments) of Azerbaijan?
Provide a succinct answer. -6.31. In the year 2007, what is the difference between the Primary completion rate (% of total enrollments) in Caribbean small states and Primary completion rate (% of total enrollments) in Lesotho?
Your response must be concise. 28.13. In the year 2007, what is the difference between the Primary completion rate (% of total enrollments) of Caribbean small states and Primary completion rate (% of total enrollments) of Samoa?
Provide a short and direct response. -18.21. In the year 2007, what is the difference between the Primary completion rate (% of total enrollments) of Azerbaijan and Primary completion rate (% of total enrollments) of Lesotho?
Your answer should be compact. 34.43. In the year 2007, what is the difference between the Primary completion rate (% of total enrollments) of Azerbaijan and Primary completion rate (% of total enrollments) of Samoa?
Make the answer very short. -11.91. In the year 2007, what is the difference between the Primary completion rate (% of total enrollments) of Lesotho and Primary completion rate (% of total enrollments) of Samoa?
Make the answer very short. -46.34. In the year 2009, what is the difference between the Primary completion rate (% of total enrollments) in Caribbean small states and Primary completion rate (% of total enrollments) in Azerbaijan?
Provide a succinct answer. -0.04. In the year 2009, what is the difference between the Primary completion rate (% of total enrollments) of Caribbean small states and Primary completion rate (% of total enrollments) of Lesotho?
Provide a succinct answer. 31.49. In the year 2009, what is the difference between the Primary completion rate (% of total enrollments) of Caribbean small states and Primary completion rate (% of total enrollments) of Samoa?
Offer a very short reply. -15.64. In the year 2009, what is the difference between the Primary completion rate (% of total enrollments) of Azerbaijan and Primary completion rate (% of total enrollments) of Lesotho?
Your answer should be compact. 31.53. In the year 2009, what is the difference between the Primary completion rate (% of total enrollments) in Azerbaijan and Primary completion rate (% of total enrollments) in Samoa?
Your answer should be very brief. -15.6. In the year 2009, what is the difference between the Primary completion rate (% of total enrollments) in Lesotho and Primary completion rate (% of total enrollments) in Samoa?
Your response must be concise. -47.13. In the year 2010, what is the difference between the Primary completion rate (% of total enrollments) of Caribbean small states and Primary completion rate (% of total enrollments) of Azerbaijan?
Your answer should be compact. 0.55. In the year 2010, what is the difference between the Primary completion rate (% of total enrollments) in Caribbean small states and Primary completion rate (% of total enrollments) in Lesotho?
Your answer should be compact. 27.27. In the year 2010, what is the difference between the Primary completion rate (% of total enrollments) of Caribbean small states and Primary completion rate (% of total enrollments) of Samoa?
Make the answer very short. -16.04. In the year 2010, what is the difference between the Primary completion rate (% of total enrollments) in Azerbaijan and Primary completion rate (% of total enrollments) in Lesotho?
Ensure brevity in your answer.  26.73. In the year 2010, what is the difference between the Primary completion rate (% of total enrollments) in Azerbaijan and Primary completion rate (% of total enrollments) in Samoa?
Provide a short and direct response. -16.59. In the year 2010, what is the difference between the Primary completion rate (% of total enrollments) of Lesotho and Primary completion rate (% of total enrollments) of Samoa?
Provide a short and direct response. -43.31. In the year 2011, what is the difference between the Primary completion rate (% of total enrollments) in Caribbean small states and Primary completion rate (% of total enrollments) in Azerbaijan?
Offer a terse response. -2.85. In the year 2011, what is the difference between the Primary completion rate (% of total enrollments) in Caribbean small states and Primary completion rate (% of total enrollments) in Lesotho?
Keep it short and to the point. 26.55. In the year 2011, what is the difference between the Primary completion rate (% of total enrollments) of Caribbean small states and Primary completion rate (% of total enrollments) of Samoa?
Make the answer very short. -11.13. In the year 2011, what is the difference between the Primary completion rate (% of total enrollments) of Azerbaijan and Primary completion rate (% of total enrollments) of Lesotho?
Offer a terse response. 29.4. In the year 2011, what is the difference between the Primary completion rate (% of total enrollments) of Azerbaijan and Primary completion rate (% of total enrollments) of Samoa?
Your response must be concise. -8.28. In the year 2011, what is the difference between the Primary completion rate (% of total enrollments) of Lesotho and Primary completion rate (% of total enrollments) of Samoa?
Provide a succinct answer. -37.68. What is the ratio of the Primary completion rate (% of total enrollments) of Caribbean small states in 1999 to that in 2000?
Give a very brief answer. 1.01. What is the ratio of the Primary completion rate (% of total enrollments) in Azerbaijan in 1999 to that in 2000?
Offer a very short reply. 0.99. What is the ratio of the Primary completion rate (% of total enrollments) in Lesotho in 1999 to that in 2000?
Keep it short and to the point. 1.03. What is the ratio of the Primary completion rate (% of total enrollments) of Samoa in 1999 to that in 2000?
Provide a short and direct response. 1.08. What is the ratio of the Primary completion rate (% of total enrollments) in Caribbean small states in 1999 to that in 2001?
Keep it short and to the point. 1.07. What is the ratio of the Primary completion rate (% of total enrollments) of Azerbaijan in 1999 to that in 2001?
Make the answer very short. 0.96. What is the ratio of the Primary completion rate (% of total enrollments) in Lesotho in 1999 to that in 2001?
Your answer should be very brief. 0.99. What is the ratio of the Primary completion rate (% of total enrollments) in Samoa in 1999 to that in 2001?
Provide a succinct answer. 1.11. What is the ratio of the Primary completion rate (% of total enrollments) in Azerbaijan in 1999 to that in 2007?
Keep it short and to the point. 0.95. What is the ratio of the Primary completion rate (% of total enrollments) of Lesotho in 1999 to that in 2007?
Offer a terse response. 0.87. What is the ratio of the Primary completion rate (% of total enrollments) of Samoa in 1999 to that in 2007?
Offer a terse response. 0.91. What is the ratio of the Primary completion rate (% of total enrollments) in Caribbean small states in 1999 to that in 2009?
Give a very brief answer. 1. What is the ratio of the Primary completion rate (% of total enrollments) in Azerbaijan in 1999 to that in 2009?
Offer a very short reply. 1.01. What is the ratio of the Primary completion rate (% of total enrollments) of Lesotho in 1999 to that in 2009?
Your answer should be very brief. 0.91. What is the ratio of the Primary completion rate (% of total enrollments) of Samoa in 1999 to that in 2009?
Offer a very short reply. 0.93. What is the ratio of the Primary completion rate (% of total enrollments) of Caribbean small states in 1999 to that in 2010?
Give a very brief answer. 1.01. What is the ratio of the Primary completion rate (% of total enrollments) of Azerbaijan in 1999 to that in 2010?
Ensure brevity in your answer.  1.03. What is the ratio of the Primary completion rate (% of total enrollments) in Lesotho in 1999 to that in 2010?
Provide a succinct answer. 0.87. What is the ratio of the Primary completion rate (% of total enrollments) of Samoa in 1999 to that in 2010?
Your answer should be very brief. 0.94. What is the ratio of the Primary completion rate (% of total enrollments) in Caribbean small states in 1999 to that in 2011?
Provide a succinct answer. 1.01. What is the ratio of the Primary completion rate (% of total enrollments) in Lesotho in 1999 to that in 2011?
Make the answer very short. 0.86. What is the ratio of the Primary completion rate (% of total enrollments) in Samoa in 1999 to that in 2011?
Make the answer very short. 0.98. What is the ratio of the Primary completion rate (% of total enrollments) in Caribbean small states in 2000 to that in 2001?
Your answer should be very brief. 1.05. What is the ratio of the Primary completion rate (% of total enrollments) of Azerbaijan in 2000 to that in 2001?
Your answer should be compact. 0.97. What is the ratio of the Primary completion rate (% of total enrollments) of Lesotho in 2000 to that in 2001?
Offer a very short reply. 0.95. What is the ratio of the Primary completion rate (% of total enrollments) in Samoa in 2000 to that in 2001?
Offer a terse response. 1.03. What is the ratio of the Primary completion rate (% of total enrollments) in Azerbaijan in 2000 to that in 2007?
Provide a succinct answer. 0.96. What is the ratio of the Primary completion rate (% of total enrollments) in Lesotho in 2000 to that in 2007?
Your response must be concise. 0.84. What is the ratio of the Primary completion rate (% of total enrollments) of Samoa in 2000 to that in 2007?
Make the answer very short. 0.85. What is the ratio of the Primary completion rate (% of total enrollments) in Caribbean small states in 2000 to that in 2009?
Your response must be concise. 0.98. What is the ratio of the Primary completion rate (% of total enrollments) of Azerbaijan in 2000 to that in 2009?
Keep it short and to the point. 1.02. What is the ratio of the Primary completion rate (% of total enrollments) of Lesotho in 2000 to that in 2009?
Offer a terse response. 0.88. What is the ratio of the Primary completion rate (% of total enrollments) in Samoa in 2000 to that in 2009?
Make the answer very short. 0.86. What is the ratio of the Primary completion rate (% of total enrollments) of Azerbaijan in 2000 to that in 2010?
Your answer should be very brief. 1.04. What is the ratio of the Primary completion rate (% of total enrollments) of Lesotho in 2000 to that in 2010?
Your answer should be compact. 0.84. What is the ratio of the Primary completion rate (% of total enrollments) in Samoa in 2000 to that in 2010?
Make the answer very short. 0.87. What is the ratio of the Primary completion rate (% of total enrollments) of Azerbaijan in 2000 to that in 2011?
Your answer should be compact. 1. What is the ratio of the Primary completion rate (% of total enrollments) in Lesotho in 2000 to that in 2011?
Your answer should be very brief. 0.83. What is the ratio of the Primary completion rate (% of total enrollments) in Samoa in 2000 to that in 2011?
Keep it short and to the point. 0.91. What is the ratio of the Primary completion rate (% of total enrollments) of Caribbean small states in 2001 to that in 2007?
Your answer should be compact. 0.94. What is the ratio of the Primary completion rate (% of total enrollments) of Lesotho in 2001 to that in 2007?
Provide a succinct answer. 0.88. What is the ratio of the Primary completion rate (% of total enrollments) of Samoa in 2001 to that in 2007?
Your answer should be compact. 0.82. What is the ratio of the Primary completion rate (% of total enrollments) in Caribbean small states in 2001 to that in 2009?
Make the answer very short. 0.93. What is the ratio of the Primary completion rate (% of total enrollments) of Azerbaijan in 2001 to that in 2009?
Your answer should be very brief. 1.05. What is the ratio of the Primary completion rate (% of total enrollments) in Lesotho in 2001 to that in 2009?
Offer a terse response. 0.92. What is the ratio of the Primary completion rate (% of total enrollments) of Samoa in 2001 to that in 2009?
Your answer should be very brief. 0.83. What is the ratio of the Primary completion rate (% of total enrollments) in Caribbean small states in 2001 to that in 2010?
Provide a succinct answer. 0.95. What is the ratio of the Primary completion rate (% of total enrollments) in Azerbaijan in 2001 to that in 2010?
Offer a terse response. 1.07. What is the ratio of the Primary completion rate (% of total enrollments) of Lesotho in 2001 to that in 2010?
Your answer should be very brief. 0.88. What is the ratio of the Primary completion rate (% of total enrollments) in Samoa in 2001 to that in 2010?
Make the answer very short. 0.84. What is the ratio of the Primary completion rate (% of total enrollments) of Caribbean small states in 2001 to that in 2011?
Ensure brevity in your answer.  0.95. What is the ratio of the Primary completion rate (% of total enrollments) in Azerbaijan in 2001 to that in 2011?
Provide a short and direct response. 1.03. What is the ratio of the Primary completion rate (% of total enrollments) of Lesotho in 2001 to that in 2011?
Give a very brief answer. 0.87. What is the ratio of the Primary completion rate (% of total enrollments) in Samoa in 2001 to that in 2011?
Make the answer very short. 0.88. What is the ratio of the Primary completion rate (% of total enrollments) of Caribbean small states in 2007 to that in 2009?
Offer a very short reply. 0.99. What is the ratio of the Primary completion rate (% of total enrollments) of Azerbaijan in 2007 to that in 2009?
Provide a short and direct response. 1.06. What is the ratio of the Primary completion rate (% of total enrollments) of Lesotho in 2007 to that in 2009?
Provide a succinct answer. 1.05. What is the ratio of the Primary completion rate (% of total enrollments) in Samoa in 2007 to that in 2009?
Give a very brief answer. 1.02. What is the ratio of the Primary completion rate (% of total enrollments) of Caribbean small states in 2007 to that in 2010?
Provide a succinct answer. 1.01. What is the ratio of the Primary completion rate (% of total enrollments) in Azerbaijan in 2007 to that in 2010?
Ensure brevity in your answer.  1.09. What is the ratio of the Primary completion rate (% of total enrollments) in Lesotho in 2007 to that in 2010?
Your answer should be compact. 1. What is the ratio of the Primary completion rate (% of total enrollments) in Samoa in 2007 to that in 2010?
Offer a very short reply. 1.03. What is the ratio of the Primary completion rate (% of total enrollments) in Caribbean small states in 2007 to that in 2011?
Offer a very short reply. 1.01. What is the ratio of the Primary completion rate (% of total enrollments) of Azerbaijan in 2007 to that in 2011?
Your response must be concise. 1.05. What is the ratio of the Primary completion rate (% of total enrollments) in Lesotho in 2007 to that in 2011?
Ensure brevity in your answer.  0.99. What is the ratio of the Primary completion rate (% of total enrollments) in Samoa in 2007 to that in 2011?
Offer a very short reply. 1.08. What is the ratio of the Primary completion rate (% of total enrollments) of Caribbean small states in 2009 to that in 2010?
Give a very brief answer. 1.02. What is the ratio of the Primary completion rate (% of total enrollments) in Azerbaijan in 2009 to that in 2010?
Provide a succinct answer. 1.02. What is the ratio of the Primary completion rate (% of total enrollments) in Lesotho in 2009 to that in 2010?
Ensure brevity in your answer.  0.96. What is the ratio of the Primary completion rate (% of total enrollments) in Samoa in 2009 to that in 2010?
Offer a very short reply. 1.01. What is the ratio of the Primary completion rate (% of total enrollments) in Caribbean small states in 2009 to that in 2011?
Make the answer very short. 1.02. What is the ratio of the Primary completion rate (% of total enrollments) in Azerbaijan in 2009 to that in 2011?
Offer a terse response. 0.99. What is the ratio of the Primary completion rate (% of total enrollments) of Lesotho in 2009 to that in 2011?
Give a very brief answer. 0.95. What is the ratio of the Primary completion rate (% of total enrollments) of Samoa in 2009 to that in 2011?
Ensure brevity in your answer.  1.06. What is the ratio of the Primary completion rate (% of total enrollments) of Azerbaijan in 2010 to that in 2011?
Provide a short and direct response. 0.96. What is the ratio of the Primary completion rate (% of total enrollments) of Samoa in 2010 to that in 2011?
Offer a very short reply. 1.05. What is the difference between the highest and the second highest Primary completion rate (% of total enrollments) in Caribbean small states?
Give a very brief answer. 0.3. What is the difference between the highest and the second highest Primary completion rate (% of total enrollments) of Azerbaijan?
Ensure brevity in your answer.  1.48. What is the difference between the highest and the second highest Primary completion rate (% of total enrollments) in Lesotho?
Offer a terse response. 0.58. What is the difference between the highest and the second highest Primary completion rate (% of total enrollments) in Samoa?
Offer a terse response. 2.03. What is the difference between the highest and the lowest Primary completion rate (% of total enrollments) of Caribbean small states?
Ensure brevity in your answer.  6.15. What is the difference between the highest and the lowest Primary completion rate (% of total enrollments) of Azerbaijan?
Offer a terse response. 7.82. What is the difference between the highest and the lowest Primary completion rate (% of total enrollments) of Lesotho?
Ensure brevity in your answer.  10.97. What is the difference between the highest and the lowest Primary completion rate (% of total enrollments) of Samoa?
Make the answer very short. 20.05. 